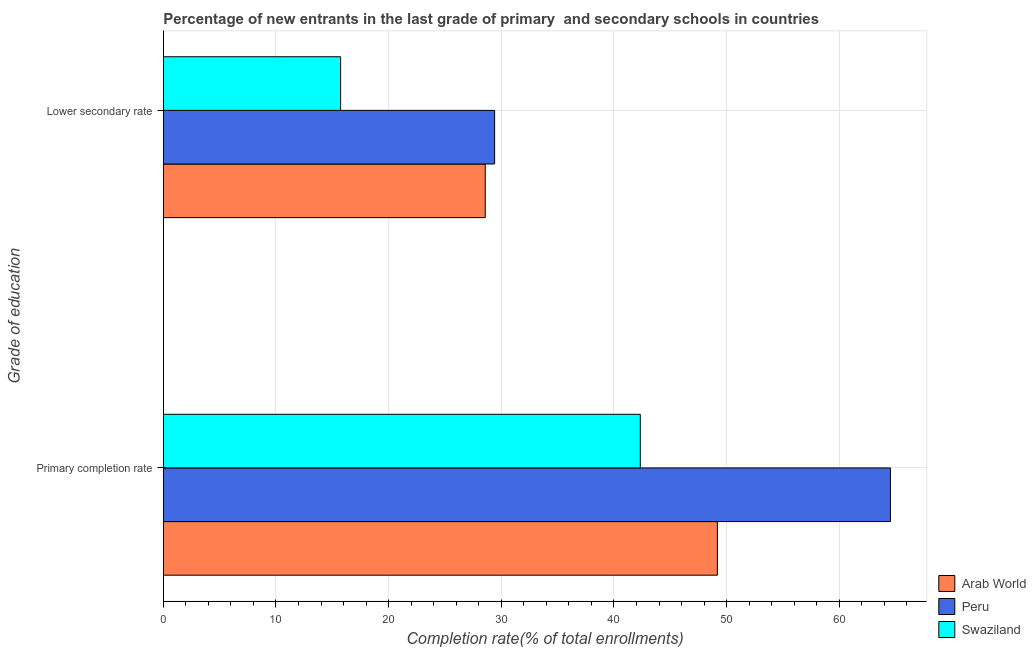How many different coloured bars are there?
Provide a succinct answer. 3. How many groups of bars are there?
Make the answer very short. 2. Are the number of bars on each tick of the Y-axis equal?
Your answer should be very brief. Yes. What is the label of the 1st group of bars from the top?
Offer a terse response. Lower secondary rate. What is the completion rate in primary schools in Peru?
Your response must be concise. 64.54. Across all countries, what is the maximum completion rate in secondary schools?
Provide a short and direct response. 29.41. Across all countries, what is the minimum completion rate in secondary schools?
Provide a short and direct response. 15.74. In which country was the completion rate in secondary schools maximum?
Provide a succinct answer. Peru. In which country was the completion rate in primary schools minimum?
Provide a succinct answer. Swaziland. What is the total completion rate in secondary schools in the graph?
Keep it short and to the point. 73.72. What is the difference between the completion rate in primary schools in Swaziland and that in Arab World?
Your answer should be very brief. -6.84. What is the difference between the completion rate in secondary schools in Arab World and the completion rate in primary schools in Swaziland?
Your answer should be compact. -13.76. What is the average completion rate in secondary schools per country?
Offer a very short reply. 24.57. What is the difference between the completion rate in primary schools and completion rate in secondary schools in Peru?
Ensure brevity in your answer.  35.13. What is the ratio of the completion rate in secondary schools in Swaziland to that in Arab World?
Offer a very short reply. 0.55. In how many countries, is the completion rate in primary schools greater than the average completion rate in primary schools taken over all countries?
Offer a very short reply. 1. What does the 1st bar from the top in Lower secondary rate represents?
Ensure brevity in your answer.  Swaziland. What does the 3rd bar from the bottom in Lower secondary rate represents?
Your answer should be very brief. Swaziland. How many bars are there?
Your answer should be compact. 6. How many countries are there in the graph?
Your answer should be compact. 3. Are the values on the major ticks of X-axis written in scientific E-notation?
Keep it short and to the point. No. Does the graph contain any zero values?
Keep it short and to the point. No. How many legend labels are there?
Give a very brief answer. 3. What is the title of the graph?
Offer a terse response. Percentage of new entrants in the last grade of primary  and secondary schools in countries. Does "Comoros" appear as one of the legend labels in the graph?
Ensure brevity in your answer.  No. What is the label or title of the X-axis?
Make the answer very short. Completion rate(% of total enrollments). What is the label or title of the Y-axis?
Offer a very short reply. Grade of education. What is the Completion rate(% of total enrollments) of Arab World in Primary completion rate?
Provide a succinct answer. 49.18. What is the Completion rate(% of total enrollments) of Peru in Primary completion rate?
Provide a succinct answer. 64.54. What is the Completion rate(% of total enrollments) in Swaziland in Primary completion rate?
Provide a short and direct response. 42.34. What is the Completion rate(% of total enrollments) in Arab World in Lower secondary rate?
Provide a succinct answer. 28.58. What is the Completion rate(% of total enrollments) of Peru in Lower secondary rate?
Offer a very short reply. 29.41. What is the Completion rate(% of total enrollments) of Swaziland in Lower secondary rate?
Provide a short and direct response. 15.74. Across all Grade of education, what is the maximum Completion rate(% of total enrollments) in Arab World?
Offer a very short reply. 49.18. Across all Grade of education, what is the maximum Completion rate(% of total enrollments) in Peru?
Keep it short and to the point. 64.54. Across all Grade of education, what is the maximum Completion rate(% of total enrollments) of Swaziland?
Make the answer very short. 42.34. Across all Grade of education, what is the minimum Completion rate(% of total enrollments) of Arab World?
Your response must be concise. 28.58. Across all Grade of education, what is the minimum Completion rate(% of total enrollments) in Peru?
Offer a very short reply. 29.41. Across all Grade of education, what is the minimum Completion rate(% of total enrollments) in Swaziland?
Offer a very short reply. 15.74. What is the total Completion rate(% of total enrollments) of Arab World in the graph?
Provide a short and direct response. 77.76. What is the total Completion rate(% of total enrollments) of Peru in the graph?
Give a very brief answer. 93.94. What is the total Completion rate(% of total enrollments) in Swaziland in the graph?
Give a very brief answer. 58.08. What is the difference between the Completion rate(% of total enrollments) of Arab World in Primary completion rate and that in Lower secondary rate?
Ensure brevity in your answer.  20.6. What is the difference between the Completion rate(% of total enrollments) of Peru in Primary completion rate and that in Lower secondary rate?
Your response must be concise. 35.13. What is the difference between the Completion rate(% of total enrollments) of Swaziland in Primary completion rate and that in Lower secondary rate?
Offer a very short reply. 26.6. What is the difference between the Completion rate(% of total enrollments) in Arab World in Primary completion rate and the Completion rate(% of total enrollments) in Peru in Lower secondary rate?
Your response must be concise. 19.77. What is the difference between the Completion rate(% of total enrollments) in Arab World in Primary completion rate and the Completion rate(% of total enrollments) in Swaziland in Lower secondary rate?
Make the answer very short. 33.44. What is the difference between the Completion rate(% of total enrollments) in Peru in Primary completion rate and the Completion rate(% of total enrollments) in Swaziland in Lower secondary rate?
Your answer should be compact. 48.8. What is the average Completion rate(% of total enrollments) in Arab World per Grade of education?
Your answer should be compact. 38.88. What is the average Completion rate(% of total enrollments) in Peru per Grade of education?
Your answer should be compact. 46.97. What is the average Completion rate(% of total enrollments) of Swaziland per Grade of education?
Offer a terse response. 29.04. What is the difference between the Completion rate(% of total enrollments) in Arab World and Completion rate(% of total enrollments) in Peru in Primary completion rate?
Your answer should be very brief. -15.36. What is the difference between the Completion rate(% of total enrollments) in Arab World and Completion rate(% of total enrollments) in Swaziland in Primary completion rate?
Provide a succinct answer. 6.84. What is the difference between the Completion rate(% of total enrollments) of Peru and Completion rate(% of total enrollments) of Swaziland in Primary completion rate?
Your answer should be very brief. 22.2. What is the difference between the Completion rate(% of total enrollments) of Arab World and Completion rate(% of total enrollments) of Peru in Lower secondary rate?
Your answer should be compact. -0.83. What is the difference between the Completion rate(% of total enrollments) in Arab World and Completion rate(% of total enrollments) in Swaziland in Lower secondary rate?
Offer a very short reply. 12.84. What is the difference between the Completion rate(% of total enrollments) in Peru and Completion rate(% of total enrollments) in Swaziland in Lower secondary rate?
Your answer should be compact. 13.67. What is the ratio of the Completion rate(% of total enrollments) in Arab World in Primary completion rate to that in Lower secondary rate?
Offer a terse response. 1.72. What is the ratio of the Completion rate(% of total enrollments) of Peru in Primary completion rate to that in Lower secondary rate?
Provide a short and direct response. 2.19. What is the ratio of the Completion rate(% of total enrollments) of Swaziland in Primary completion rate to that in Lower secondary rate?
Give a very brief answer. 2.69. What is the difference between the highest and the second highest Completion rate(% of total enrollments) of Arab World?
Ensure brevity in your answer.  20.6. What is the difference between the highest and the second highest Completion rate(% of total enrollments) of Peru?
Ensure brevity in your answer.  35.13. What is the difference between the highest and the second highest Completion rate(% of total enrollments) in Swaziland?
Provide a short and direct response. 26.6. What is the difference between the highest and the lowest Completion rate(% of total enrollments) in Arab World?
Provide a succinct answer. 20.6. What is the difference between the highest and the lowest Completion rate(% of total enrollments) of Peru?
Offer a terse response. 35.13. What is the difference between the highest and the lowest Completion rate(% of total enrollments) of Swaziland?
Your answer should be compact. 26.6. 